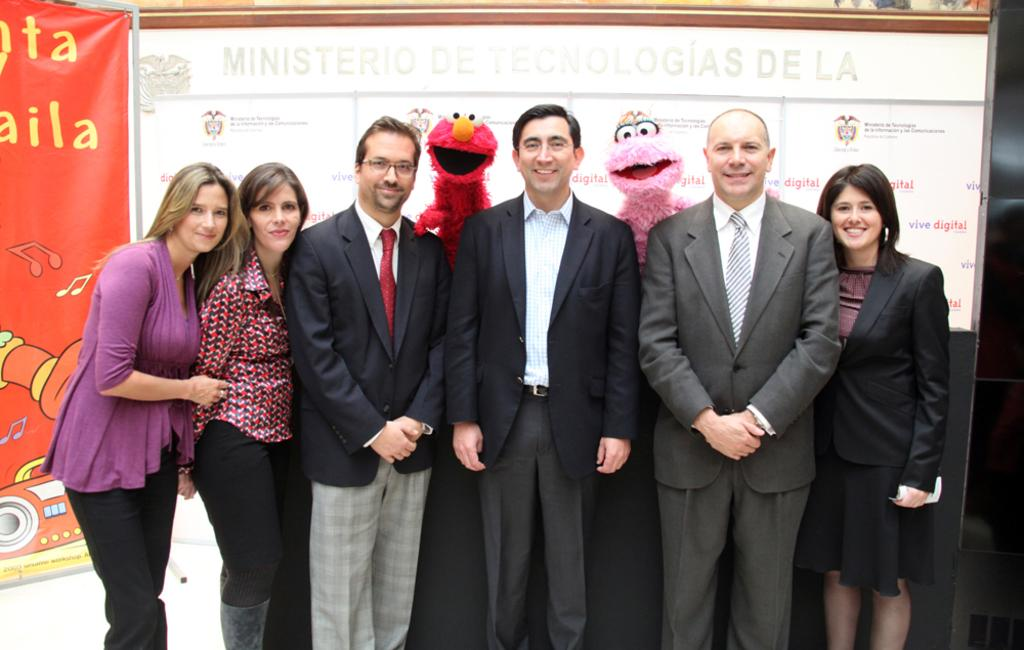What can be seen in the image involving people? There are people standing in the image. What other characters are present in the image? There are mascots in the image. What can be seen in the background of the image? There is a board and a banner in the background of the image. What type of stone is being used to play with the toys in the image? There is no stone or toys present in the image. What color is the silver used to decorate the mascots in the image? There is: There is no silver present in the image; the mascots' colors are not mentioned. 